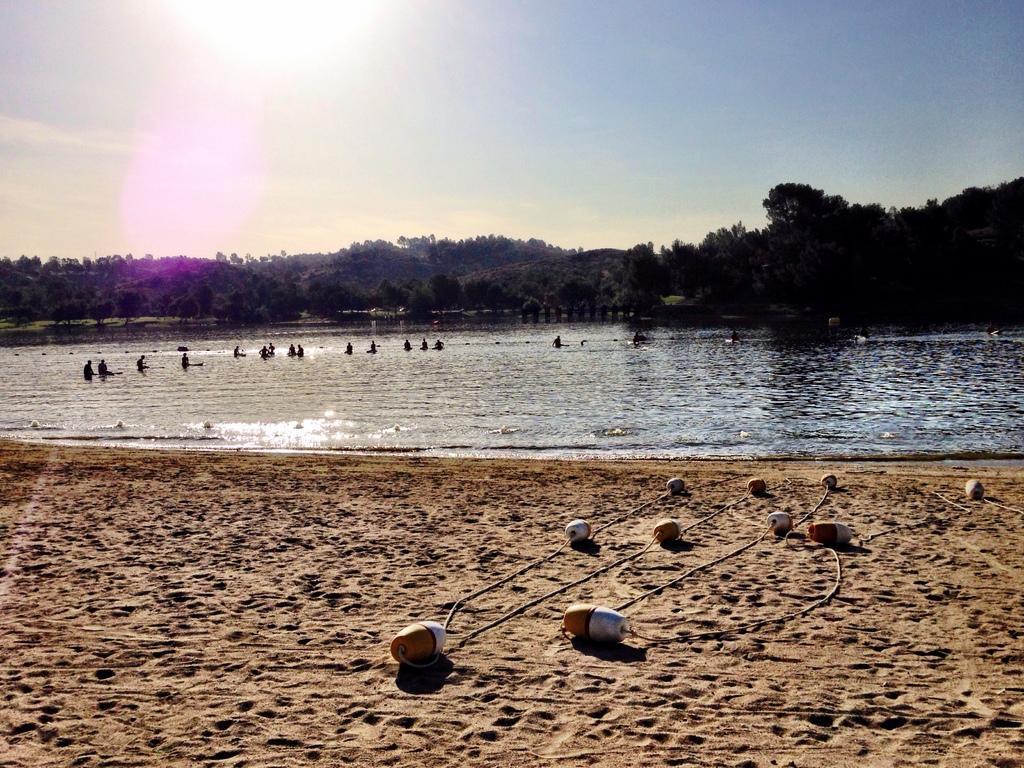In one or two sentences, can you explain what this image depicts? In this image there are some objects on the sand, group of people in the water, trees, and in the background there is sky. 